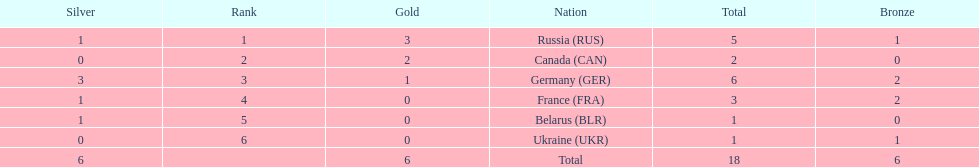Who had a larger total medal count, france or canada? France. 